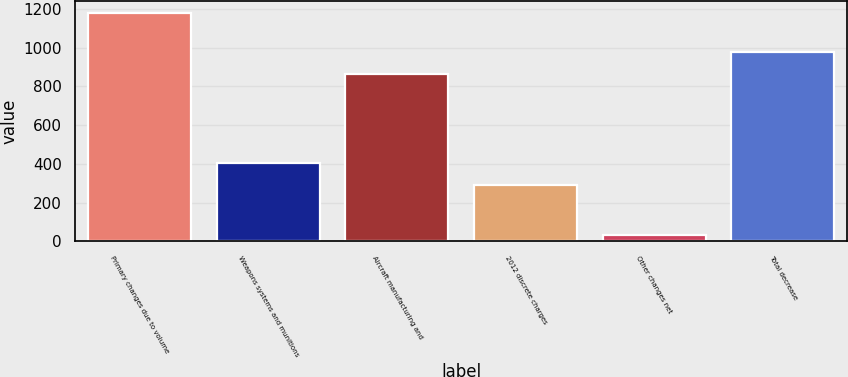Convert chart to OTSL. <chart><loc_0><loc_0><loc_500><loc_500><bar_chart><fcel>Primary changes due to volume<fcel>Weapons systems and munitions<fcel>Aircraft manufacturing and<fcel>2012 discrete charges<fcel>Other changes net<fcel>Total decrease<nl><fcel>1180<fcel>403.9<fcel>864<fcel>289<fcel>31<fcel>978.9<nl></chart> 